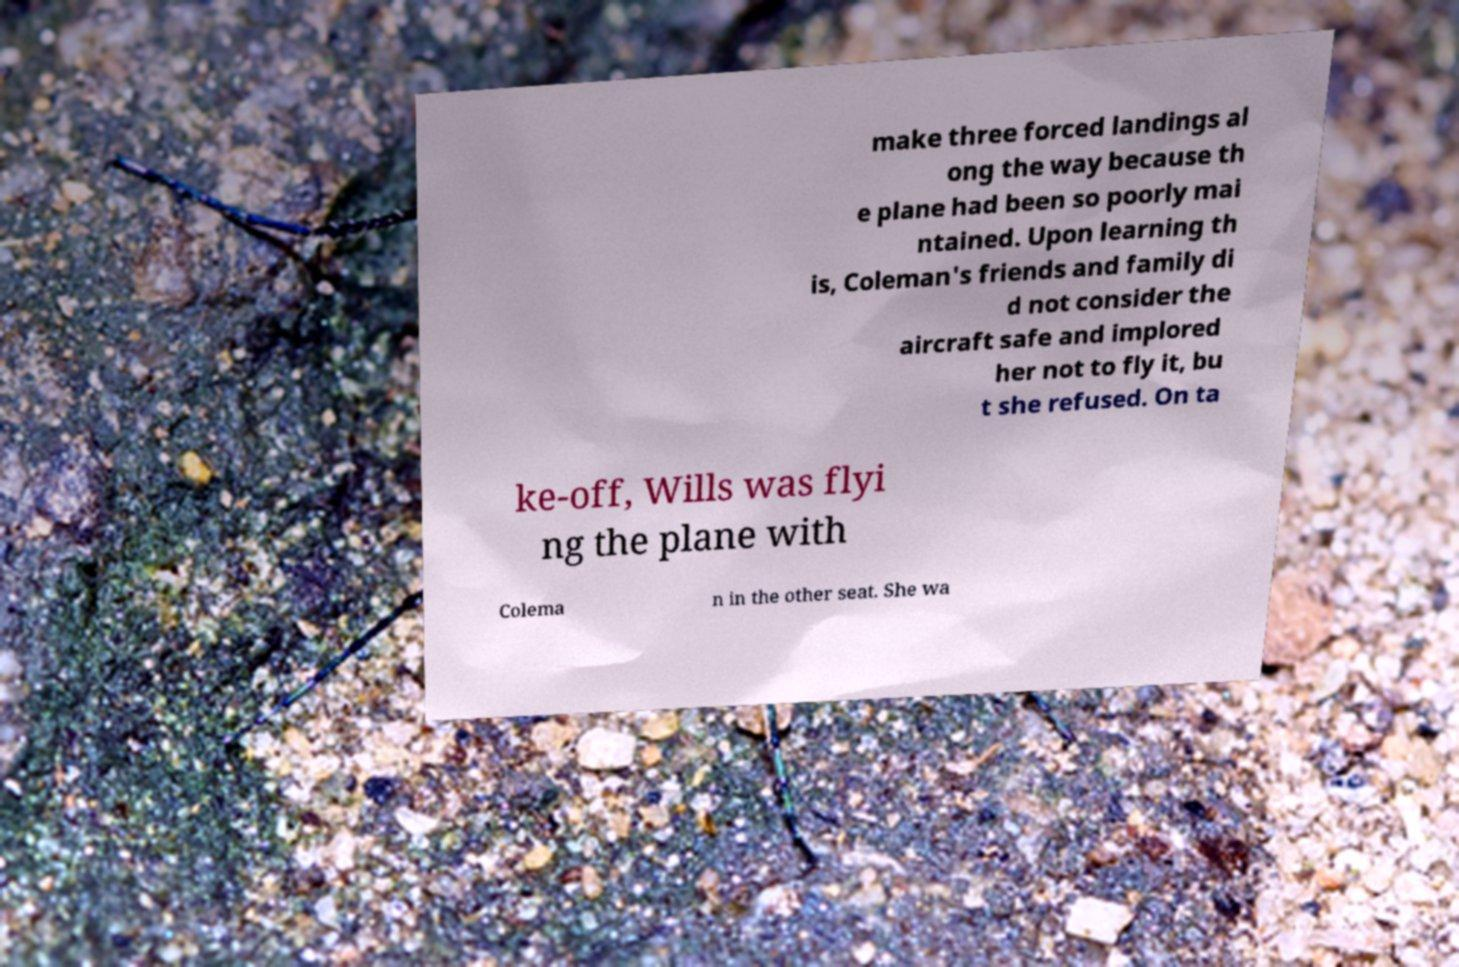Please identify and transcribe the text found in this image. make three forced landings al ong the way because th e plane had been so poorly mai ntained. Upon learning th is, Coleman's friends and family di d not consider the aircraft safe and implored her not to fly it, bu t she refused. On ta ke-off, Wills was flyi ng the plane with Colema n in the other seat. She wa 